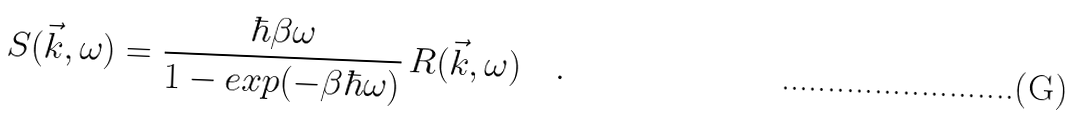<formula> <loc_0><loc_0><loc_500><loc_500>S ( \vec { k } , \omega ) = \frac { \hbar { \beta } \omega } { 1 - e x p ( - \beta \hbar { \omega } ) } \, R ( \vec { k } , \omega ) \quad .</formula> 